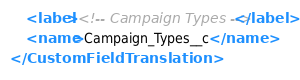<code> <loc_0><loc_0><loc_500><loc_500><_XML_>    <label><!-- Campaign Types --></label>
    <name>Campaign_Types__c</name>
</CustomFieldTranslation>
</code> 